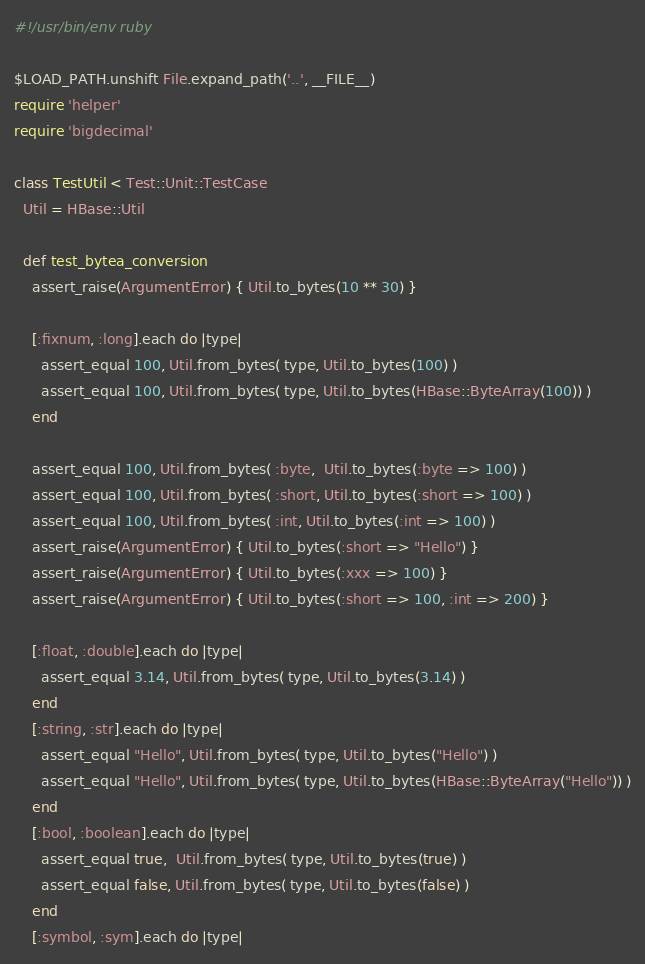Convert code to text. <code><loc_0><loc_0><loc_500><loc_500><_Ruby_>#!/usr/bin/env ruby

$LOAD_PATH.unshift File.expand_path('..', __FILE__)
require 'helper'
require 'bigdecimal'

class TestUtil < Test::Unit::TestCase
  Util = HBase::Util

  def test_bytea_conversion
    assert_raise(ArgumentError) { Util.to_bytes(10 ** 30) }

    [:fixnum, :long].each do |type|
      assert_equal 100, Util.from_bytes( type, Util.to_bytes(100) )
      assert_equal 100, Util.from_bytes( type, Util.to_bytes(HBase::ByteArray(100)) )
    end

    assert_equal 100, Util.from_bytes( :byte,  Util.to_bytes(:byte => 100) )
    assert_equal 100, Util.from_bytes( :short, Util.to_bytes(:short => 100) )
    assert_equal 100, Util.from_bytes( :int, Util.to_bytes(:int => 100) )
    assert_raise(ArgumentError) { Util.to_bytes(:short => "Hello") }
    assert_raise(ArgumentError) { Util.to_bytes(:xxx => 100) }
    assert_raise(ArgumentError) { Util.to_bytes(:short => 100, :int => 200) }

    [:float, :double].each do |type|
      assert_equal 3.14, Util.from_bytes( type, Util.to_bytes(3.14) )
    end
    [:string, :str].each do |type|
      assert_equal "Hello", Util.from_bytes( type, Util.to_bytes("Hello") )
      assert_equal "Hello", Util.from_bytes( type, Util.to_bytes(HBase::ByteArray("Hello")) )
    end
    [:bool, :boolean].each do |type|
      assert_equal true,  Util.from_bytes( type, Util.to_bytes(true) )
      assert_equal false, Util.from_bytes( type, Util.to_bytes(false) )
    end
    [:symbol, :sym].each do |type|</code> 